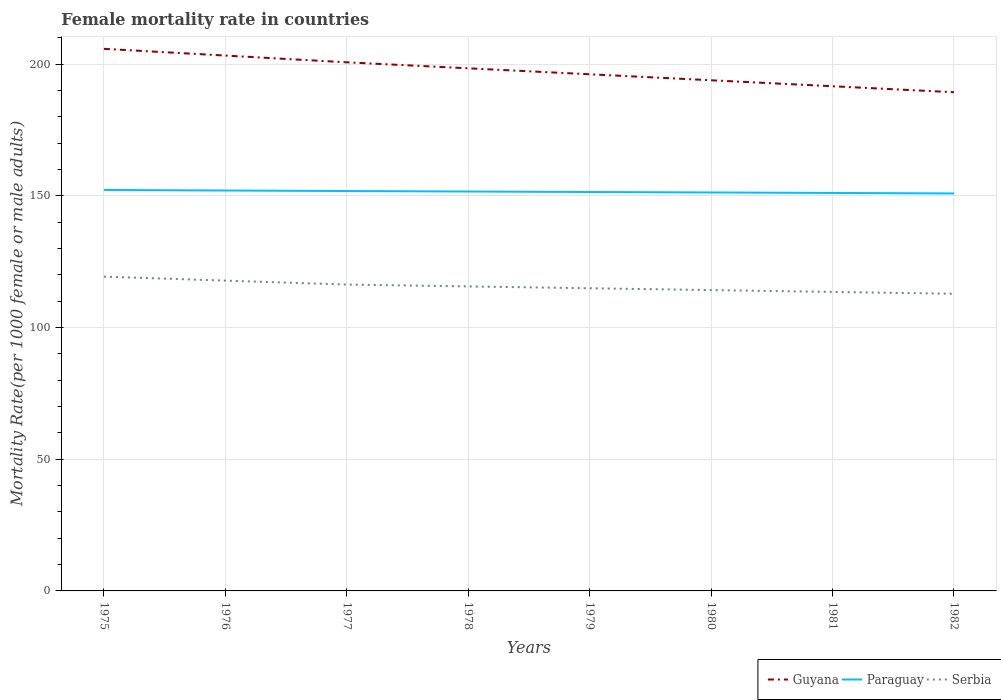Does the line corresponding to Guyana intersect with the line corresponding to Serbia?
Keep it short and to the point. No. Across all years, what is the maximum female mortality rate in Paraguay?
Offer a very short reply. 150.9. In which year was the female mortality rate in Guyana maximum?
Give a very brief answer. 1982. What is the total female mortality rate in Paraguay in the graph?
Ensure brevity in your answer.  0.57. What is the difference between the highest and the second highest female mortality rate in Guyana?
Keep it short and to the point. 16.48. Is the female mortality rate in Guyana strictly greater than the female mortality rate in Serbia over the years?
Offer a terse response. No. Does the graph contain any zero values?
Your answer should be very brief. No. How are the legend labels stacked?
Offer a very short reply. Horizontal. What is the title of the graph?
Ensure brevity in your answer.  Female mortality rate in countries. What is the label or title of the Y-axis?
Your response must be concise. Mortality Rate(per 1000 female or male adults). What is the Mortality Rate(per 1000 female or male adults) of Guyana in 1975?
Offer a terse response. 205.79. What is the Mortality Rate(per 1000 female or male adults) of Paraguay in 1975?
Make the answer very short. 152.21. What is the Mortality Rate(per 1000 female or male adults) of Serbia in 1975?
Give a very brief answer. 119.3. What is the Mortality Rate(per 1000 female or male adults) in Guyana in 1976?
Your answer should be very brief. 203.23. What is the Mortality Rate(per 1000 female or male adults) of Paraguay in 1976?
Provide a succinct answer. 152.01. What is the Mortality Rate(per 1000 female or male adults) of Serbia in 1976?
Keep it short and to the point. 117.8. What is the Mortality Rate(per 1000 female or male adults) of Guyana in 1977?
Your answer should be very brief. 200.67. What is the Mortality Rate(per 1000 female or male adults) of Paraguay in 1977?
Ensure brevity in your answer.  151.8. What is the Mortality Rate(per 1000 female or male adults) in Serbia in 1977?
Offer a very short reply. 116.3. What is the Mortality Rate(per 1000 female or male adults) in Guyana in 1978?
Offer a very short reply. 198.4. What is the Mortality Rate(per 1000 female or male adults) of Paraguay in 1978?
Give a very brief answer. 151.62. What is the Mortality Rate(per 1000 female or male adults) in Serbia in 1978?
Offer a very short reply. 115.6. What is the Mortality Rate(per 1000 female or male adults) in Guyana in 1979?
Keep it short and to the point. 196.13. What is the Mortality Rate(per 1000 female or male adults) in Paraguay in 1979?
Provide a succinct answer. 151.44. What is the Mortality Rate(per 1000 female or male adults) in Serbia in 1979?
Offer a very short reply. 114.9. What is the Mortality Rate(per 1000 female or male adults) of Guyana in 1980?
Your response must be concise. 193.86. What is the Mortality Rate(per 1000 female or male adults) in Paraguay in 1980?
Provide a succinct answer. 151.26. What is the Mortality Rate(per 1000 female or male adults) in Serbia in 1980?
Give a very brief answer. 114.2. What is the Mortality Rate(per 1000 female or male adults) in Guyana in 1981?
Offer a very short reply. 191.59. What is the Mortality Rate(per 1000 female or male adults) in Paraguay in 1981?
Offer a terse response. 151.08. What is the Mortality Rate(per 1000 female or male adults) in Serbia in 1981?
Provide a succinct answer. 113.5. What is the Mortality Rate(per 1000 female or male adults) of Guyana in 1982?
Your response must be concise. 189.31. What is the Mortality Rate(per 1000 female or male adults) in Paraguay in 1982?
Offer a terse response. 150.9. What is the Mortality Rate(per 1000 female or male adults) in Serbia in 1982?
Ensure brevity in your answer.  112.81. Across all years, what is the maximum Mortality Rate(per 1000 female or male adults) in Guyana?
Make the answer very short. 205.79. Across all years, what is the maximum Mortality Rate(per 1000 female or male adults) in Paraguay?
Your response must be concise. 152.21. Across all years, what is the maximum Mortality Rate(per 1000 female or male adults) of Serbia?
Your response must be concise. 119.3. Across all years, what is the minimum Mortality Rate(per 1000 female or male adults) in Guyana?
Your answer should be very brief. 189.31. Across all years, what is the minimum Mortality Rate(per 1000 female or male adults) in Paraguay?
Provide a short and direct response. 150.9. Across all years, what is the minimum Mortality Rate(per 1000 female or male adults) of Serbia?
Your answer should be very brief. 112.81. What is the total Mortality Rate(per 1000 female or male adults) of Guyana in the graph?
Your answer should be very brief. 1578.97. What is the total Mortality Rate(per 1000 female or male adults) of Paraguay in the graph?
Provide a succinct answer. 1212.32. What is the total Mortality Rate(per 1000 female or male adults) of Serbia in the graph?
Keep it short and to the point. 924.41. What is the difference between the Mortality Rate(per 1000 female or male adults) of Guyana in 1975 and that in 1976?
Make the answer very short. 2.56. What is the difference between the Mortality Rate(per 1000 female or male adults) in Paraguay in 1975 and that in 1976?
Your answer should be very brief. 0.2. What is the difference between the Mortality Rate(per 1000 female or male adults) in Serbia in 1975 and that in 1976?
Your answer should be very brief. 1.5. What is the difference between the Mortality Rate(per 1000 female or male adults) of Guyana in 1975 and that in 1977?
Provide a short and direct response. 5.12. What is the difference between the Mortality Rate(per 1000 female or male adults) of Paraguay in 1975 and that in 1977?
Provide a succinct answer. 0.41. What is the difference between the Mortality Rate(per 1000 female or male adults) of Serbia in 1975 and that in 1977?
Provide a succinct answer. 3. What is the difference between the Mortality Rate(per 1000 female or male adults) of Guyana in 1975 and that in 1978?
Offer a terse response. 7.39. What is the difference between the Mortality Rate(per 1000 female or male adults) in Paraguay in 1975 and that in 1978?
Your answer should be very brief. 0.59. What is the difference between the Mortality Rate(per 1000 female or male adults) in Serbia in 1975 and that in 1978?
Your answer should be very brief. 3.7. What is the difference between the Mortality Rate(per 1000 female or male adults) in Guyana in 1975 and that in 1979?
Offer a very short reply. 9.66. What is the difference between the Mortality Rate(per 1000 female or male adults) of Paraguay in 1975 and that in 1979?
Provide a succinct answer. 0.77. What is the difference between the Mortality Rate(per 1000 female or male adults) of Serbia in 1975 and that in 1979?
Ensure brevity in your answer.  4.4. What is the difference between the Mortality Rate(per 1000 female or male adults) in Guyana in 1975 and that in 1980?
Make the answer very short. 11.94. What is the difference between the Mortality Rate(per 1000 female or male adults) of Paraguay in 1975 and that in 1980?
Ensure brevity in your answer.  0.95. What is the difference between the Mortality Rate(per 1000 female or male adults) of Serbia in 1975 and that in 1980?
Keep it short and to the point. 5.1. What is the difference between the Mortality Rate(per 1000 female or male adults) in Guyana in 1975 and that in 1981?
Your response must be concise. 14.21. What is the difference between the Mortality Rate(per 1000 female or male adults) of Paraguay in 1975 and that in 1981?
Provide a short and direct response. 1.14. What is the difference between the Mortality Rate(per 1000 female or male adults) of Serbia in 1975 and that in 1981?
Your response must be concise. 5.8. What is the difference between the Mortality Rate(per 1000 female or male adults) of Guyana in 1975 and that in 1982?
Ensure brevity in your answer.  16.48. What is the difference between the Mortality Rate(per 1000 female or male adults) in Paraguay in 1975 and that in 1982?
Provide a short and direct response. 1.32. What is the difference between the Mortality Rate(per 1000 female or male adults) in Serbia in 1975 and that in 1982?
Provide a succinct answer. 6.49. What is the difference between the Mortality Rate(per 1000 female or male adults) of Guyana in 1976 and that in 1977?
Make the answer very short. 2.56. What is the difference between the Mortality Rate(per 1000 female or male adults) in Paraguay in 1976 and that in 1977?
Keep it short and to the point. 0.2. What is the difference between the Mortality Rate(per 1000 female or male adults) of Serbia in 1976 and that in 1977?
Your answer should be compact. 1.5. What is the difference between the Mortality Rate(per 1000 female or male adults) in Guyana in 1976 and that in 1978?
Provide a succinct answer. 4.83. What is the difference between the Mortality Rate(per 1000 female or male adults) in Paraguay in 1976 and that in 1978?
Provide a succinct answer. 0.39. What is the difference between the Mortality Rate(per 1000 female or male adults) of Serbia in 1976 and that in 1978?
Give a very brief answer. 2.2. What is the difference between the Mortality Rate(per 1000 female or male adults) in Guyana in 1976 and that in 1979?
Ensure brevity in your answer.  7.1. What is the difference between the Mortality Rate(per 1000 female or male adults) of Paraguay in 1976 and that in 1979?
Provide a succinct answer. 0.57. What is the difference between the Mortality Rate(per 1000 female or male adults) of Serbia in 1976 and that in 1979?
Make the answer very short. 2.9. What is the difference between the Mortality Rate(per 1000 female or male adults) in Guyana in 1976 and that in 1980?
Your answer should be compact. 9.37. What is the difference between the Mortality Rate(per 1000 female or male adults) of Paraguay in 1976 and that in 1980?
Your answer should be very brief. 0.75. What is the difference between the Mortality Rate(per 1000 female or male adults) in Serbia in 1976 and that in 1980?
Ensure brevity in your answer.  3.6. What is the difference between the Mortality Rate(per 1000 female or male adults) in Guyana in 1976 and that in 1981?
Provide a succinct answer. 11.64. What is the difference between the Mortality Rate(per 1000 female or male adults) in Paraguay in 1976 and that in 1981?
Offer a terse response. 0.93. What is the difference between the Mortality Rate(per 1000 female or male adults) of Serbia in 1976 and that in 1981?
Give a very brief answer. 4.29. What is the difference between the Mortality Rate(per 1000 female or male adults) in Guyana in 1976 and that in 1982?
Keep it short and to the point. 13.91. What is the difference between the Mortality Rate(per 1000 female or male adults) in Paraguay in 1976 and that in 1982?
Offer a very short reply. 1.11. What is the difference between the Mortality Rate(per 1000 female or male adults) of Serbia in 1976 and that in 1982?
Offer a terse response. 4.99. What is the difference between the Mortality Rate(per 1000 female or male adults) in Guyana in 1977 and that in 1978?
Your response must be concise. 2.27. What is the difference between the Mortality Rate(per 1000 female or male adults) of Paraguay in 1977 and that in 1978?
Offer a very short reply. 0.18. What is the difference between the Mortality Rate(per 1000 female or male adults) in Serbia in 1977 and that in 1978?
Your response must be concise. 0.7. What is the difference between the Mortality Rate(per 1000 female or male adults) in Guyana in 1977 and that in 1979?
Give a very brief answer. 4.54. What is the difference between the Mortality Rate(per 1000 female or male adults) in Paraguay in 1977 and that in 1979?
Offer a very short reply. 0.36. What is the difference between the Mortality Rate(per 1000 female or male adults) of Serbia in 1977 and that in 1979?
Provide a succinct answer. 1.4. What is the difference between the Mortality Rate(per 1000 female or male adults) of Guyana in 1977 and that in 1980?
Make the answer very short. 6.81. What is the difference between the Mortality Rate(per 1000 female or male adults) of Paraguay in 1977 and that in 1980?
Ensure brevity in your answer.  0.55. What is the difference between the Mortality Rate(per 1000 female or male adults) of Serbia in 1977 and that in 1980?
Ensure brevity in your answer.  2.1. What is the difference between the Mortality Rate(per 1000 female or male adults) of Guyana in 1977 and that in 1981?
Your response must be concise. 9.08. What is the difference between the Mortality Rate(per 1000 female or male adults) in Paraguay in 1977 and that in 1981?
Make the answer very short. 0.73. What is the difference between the Mortality Rate(per 1000 female or male adults) in Serbia in 1977 and that in 1981?
Keep it short and to the point. 2.79. What is the difference between the Mortality Rate(per 1000 female or male adults) of Guyana in 1977 and that in 1982?
Keep it short and to the point. 11.35. What is the difference between the Mortality Rate(per 1000 female or male adults) in Paraguay in 1977 and that in 1982?
Make the answer very short. 0.91. What is the difference between the Mortality Rate(per 1000 female or male adults) of Serbia in 1977 and that in 1982?
Provide a short and direct response. 3.49. What is the difference between the Mortality Rate(per 1000 female or male adults) in Guyana in 1978 and that in 1979?
Offer a terse response. 2.27. What is the difference between the Mortality Rate(per 1000 female or male adults) in Paraguay in 1978 and that in 1979?
Offer a terse response. 0.18. What is the difference between the Mortality Rate(per 1000 female or male adults) in Serbia in 1978 and that in 1979?
Your answer should be very brief. 0.7. What is the difference between the Mortality Rate(per 1000 female or male adults) in Guyana in 1978 and that in 1980?
Your answer should be compact. 4.54. What is the difference between the Mortality Rate(per 1000 female or male adults) in Paraguay in 1978 and that in 1980?
Offer a terse response. 0.36. What is the difference between the Mortality Rate(per 1000 female or male adults) of Serbia in 1978 and that in 1980?
Your answer should be very brief. 1.4. What is the difference between the Mortality Rate(per 1000 female or male adults) of Guyana in 1978 and that in 1981?
Make the answer very short. 6.81. What is the difference between the Mortality Rate(per 1000 female or male adults) in Paraguay in 1978 and that in 1981?
Your answer should be very brief. 0.55. What is the difference between the Mortality Rate(per 1000 female or male adults) in Serbia in 1978 and that in 1981?
Offer a very short reply. 2.1. What is the difference between the Mortality Rate(per 1000 female or male adults) of Guyana in 1978 and that in 1982?
Your response must be concise. 9.08. What is the difference between the Mortality Rate(per 1000 female or male adults) in Paraguay in 1978 and that in 1982?
Your response must be concise. 0.73. What is the difference between the Mortality Rate(per 1000 female or male adults) in Serbia in 1978 and that in 1982?
Provide a short and direct response. 2.79. What is the difference between the Mortality Rate(per 1000 female or male adults) in Guyana in 1979 and that in 1980?
Offer a very short reply. 2.27. What is the difference between the Mortality Rate(per 1000 female or male adults) of Paraguay in 1979 and that in 1980?
Provide a succinct answer. 0.18. What is the difference between the Mortality Rate(per 1000 female or male adults) of Serbia in 1979 and that in 1980?
Give a very brief answer. 0.7. What is the difference between the Mortality Rate(per 1000 female or male adults) in Guyana in 1979 and that in 1981?
Provide a short and direct response. 4.54. What is the difference between the Mortality Rate(per 1000 female or male adults) in Paraguay in 1979 and that in 1981?
Provide a short and direct response. 0.36. What is the difference between the Mortality Rate(per 1000 female or male adults) in Serbia in 1979 and that in 1981?
Keep it short and to the point. 1.4. What is the difference between the Mortality Rate(per 1000 female or male adults) of Guyana in 1979 and that in 1982?
Your response must be concise. 6.81. What is the difference between the Mortality Rate(per 1000 female or male adults) in Paraguay in 1979 and that in 1982?
Your response must be concise. 0.55. What is the difference between the Mortality Rate(per 1000 female or male adults) in Serbia in 1979 and that in 1982?
Your response must be concise. 2.1. What is the difference between the Mortality Rate(per 1000 female or male adults) in Guyana in 1980 and that in 1981?
Give a very brief answer. 2.27. What is the difference between the Mortality Rate(per 1000 female or male adults) of Paraguay in 1980 and that in 1981?
Provide a succinct answer. 0.18. What is the difference between the Mortality Rate(per 1000 female or male adults) in Serbia in 1980 and that in 1981?
Your answer should be compact. 0.7. What is the difference between the Mortality Rate(per 1000 female or male adults) of Guyana in 1980 and that in 1982?
Make the answer very short. 4.54. What is the difference between the Mortality Rate(per 1000 female or male adults) of Paraguay in 1980 and that in 1982?
Provide a short and direct response. 0.36. What is the difference between the Mortality Rate(per 1000 female or male adults) in Serbia in 1980 and that in 1982?
Your answer should be compact. 1.4. What is the difference between the Mortality Rate(per 1000 female or male adults) in Guyana in 1981 and that in 1982?
Your answer should be very brief. 2.27. What is the difference between the Mortality Rate(per 1000 female or male adults) in Paraguay in 1981 and that in 1982?
Offer a terse response. 0.18. What is the difference between the Mortality Rate(per 1000 female or male adults) in Serbia in 1981 and that in 1982?
Your answer should be very brief. 0.7. What is the difference between the Mortality Rate(per 1000 female or male adults) in Guyana in 1975 and the Mortality Rate(per 1000 female or male adults) in Paraguay in 1976?
Offer a terse response. 53.78. What is the difference between the Mortality Rate(per 1000 female or male adults) in Guyana in 1975 and the Mortality Rate(per 1000 female or male adults) in Serbia in 1976?
Your answer should be very brief. 87.99. What is the difference between the Mortality Rate(per 1000 female or male adults) in Paraguay in 1975 and the Mortality Rate(per 1000 female or male adults) in Serbia in 1976?
Offer a very short reply. 34.41. What is the difference between the Mortality Rate(per 1000 female or male adults) of Guyana in 1975 and the Mortality Rate(per 1000 female or male adults) of Paraguay in 1977?
Your answer should be compact. 53.99. What is the difference between the Mortality Rate(per 1000 female or male adults) of Guyana in 1975 and the Mortality Rate(per 1000 female or male adults) of Serbia in 1977?
Your answer should be very brief. 89.49. What is the difference between the Mortality Rate(per 1000 female or male adults) of Paraguay in 1975 and the Mortality Rate(per 1000 female or male adults) of Serbia in 1977?
Provide a short and direct response. 35.91. What is the difference between the Mortality Rate(per 1000 female or male adults) of Guyana in 1975 and the Mortality Rate(per 1000 female or male adults) of Paraguay in 1978?
Your response must be concise. 54.17. What is the difference between the Mortality Rate(per 1000 female or male adults) of Guyana in 1975 and the Mortality Rate(per 1000 female or male adults) of Serbia in 1978?
Your response must be concise. 90.19. What is the difference between the Mortality Rate(per 1000 female or male adults) of Paraguay in 1975 and the Mortality Rate(per 1000 female or male adults) of Serbia in 1978?
Keep it short and to the point. 36.61. What is the difference between the Mortality Rate(per 1000 female or male adults) in Guyana in 1975 and the Mortality Rate(per 1000 female or male adults) in Paraguay in 1979?
Provide a short and direct response. 54.35. What is the difference between the Mortality Rate(per 1000 female or male adults) in Guyana in 1975 and the Mortality Rate(per 1000 female or male adults) in Serbia in 1979?
Give a very brief answer. 90.89. What is the difference between the Mortality Rate(per 1000 female or male adults) in Paraguay in 1975 and the Mortality Rate(per 1000 female or male adults) in Serbia in 1979?
Give a very brief answer. 37.31. What is the difference between the Mortality Rate(per 1000 female or male adults) of Guyana in 1975 and the Mortality Rate(per 1000 female or male adults) of Paraguay in 1980?
Keep it short and to the point. 54.53. What is the difference between the Mortality Rate(per 1000 female or male adults) of Guyana in 1975 and the Mortality Rate(per 1000 female or male adults) of Serbia in 1980?
Offer a terse response. 91.59. What is the difference between the Mortality Rate(per 1000 female or male adults) of Paraguay in 1975 and the Mortality Rate(per 1000 female or male adults) of Serbia in 1980?
Provide a short and direct response. 38.01. What is the difference between the Mortality Rate(per 1000 female or male adults) of Guyana in 1975 and the Mortality Rate(per 1000 female or male adults) of Paraguay in 1981?
Your answer should be compact. 54.71. What is the difference between the Mortality Rate(per 1000 female or male adults) of Guyana in 1975 and the Mortality Rate(per 1000 female or male adults) of Serbia in 1981?
Your response must be concise. 92.29. What is the difference between the Mortality Rate(per 1000 female or male adults) in Paraguay in 1975 and the Mortality Rate(per 1000 female or male adults) in Serbia in 1981?
Keep it short and to the point. 38.71. What is the difference between the Mortality Rate(per 1000 female or male adults) in Guyana in 1975 and the Mortality Rate(per 1000 female or male adults) in Paraguay in 1982?
Offer a terse response. 54.9. What is the difference between the Mortality Rate(per 1000 female or male adults) in Guyana in 1975 and the Mortality Rate(per 1000 female or male adults) in Serbia in 1982?
Offer a terse response. 92.99. What is the difference between the Mortality Rate(per 1000 female or male adults) in Paraguay in 1975 and the Mortality Rate(per 1000 female or male adults) in Serbia in 1982?
Provide a short and direct response. 39.41. What is the difference between the Mortality Rate(per 1000 female or male adults) of Guyana in 1976 and the Mortality Rate(per 1000 female or male adults) of Paraguay in 1977?
Offer a terse response. 51.42. What is the difference between the Mortality Rate(per 1000 female or male adults) in Guyana in 1976 and the Mortality Rate(per 1000 female or male adults) in Serbia in 1977?
Provide a short and direct response. 86.93. What is the difference between the Mortality Rate(per 1000 female or male adults) of Paraguay in 1976 and the Mortality Rate(per 1000 female or male adults) of Serbia in 1977?
Make the answer very short. 35.71. What is the difference between the Mortality Rate(per 1000 female or male adults) of Guyana in 1976 and the Mortality Rate(per 1000 female or male adults) of Paraguay in 1978?
Provide a short and direct response. 51.61. What is the difference between the Mortality Rate(per 1000 female or male adults) in Guyana in 1976 and the Mortality Rate(per 1000 female or male adults) in Serbia in 1978?
Ensure brevity in your answer.  87.63. What is the difference between the Mortality Rate(per 1000 female or male adults) in Paraguay in 1976 and the Mortality Rate(per 1000 female or male adults) in Serbia in 1978?
Keep it short and to the point. 36.41. What is the difference between the Mortality Rate(per 1000 female or male adults) of Guyana in 1976 and the Mortality Rate(per 1000 female or male adults) of Paraguay in 1979?
Offer a very short reply. 51.79. What is the difference between the Mortality Rate(per 1000 female or male adults) of Guyana in 1976 and the Mortality Rate(per 1000 female or male adults) of Serbia in 1979?
Ensure brevity in your answer.  88.33. What is the difference between the Mortality Rate(per 1000 female or male adults) in Paraguay in 1976 and the Mortality Rate(per 1000 female or male adults) in Serbia in 1979?
Provide a succinct answer. 37.11. What is the difference between the Mortality Rate(per 1000 female or male adults) of Guyana in 1976 and the Mortality Rate(per 1000 female or male adults) of Paraguay in 1980?
Provide a short and direct response. 51.97. What is the difference between the Mortality Rate(per 1000 female or male adults) in Guyana in 1976 and the Mortality Rate(per 1000 female or male adults) in Serbia in 1980?
Make the answer very short. 89.03. What is the difference between the Mortality Rate(per 1000 female or male adults) of Paraguay in 1976 and the Mortality Rate(per 1000 female or male adults) of Serbia in 1980?
Your response must be concise. 37.81. What is the difference between the Mortality Rate(per 1000 female or male adults) in Guyana in 1976 and the Mortality Rate(per 1000 female or male adults) in Paraguay in 1981?
Ensure brevity in your answer.  52.15. What is the difference between the Mortality Rate(per 1000 female or male adults) of Guyana in 1976 and the Mortality Rate(per 1000 female or male adults) of Serbia in 1981?
Give a very brief answer. 89.73. What is the difference between the Mortality Rate(per 1000 female or male adults) in Paraguay in 1976 and the Mortality Rate(per 1000 female or male adults) in Serbia in 1981?
Provide a short and direct response. 38.5. What is the difference between the Mortality Rate(per 1000 female or male adults) of Guyana in 1976 and the Mortality Rate(per 1000 female or male adults) of Paraguay in 1982?
Make the answer very short. 52.33. What is the difference between the Mortality Rate(per 1000 female or male adults) of Guyana in 1976 and the Mortality Rate(per 1000 female or male adults) of Serbia in 1982?
Your response must be concise. 90.42. What is the difference between the Mortality Rate(per 1000 female or male adults) in Paraguay in 1976 and the Mortality Rate(per 1000 female or male adults) in Serbia in 1982?
Your answer should be very brief. 39.2. What is the difference between the Mortality Rate(per 1000 female or male adults) in Guyana in 1977 and the Mortality Rate(per 1000 female or male adults) in Paraguay in 1978?
Provide a short and direct response. 49.05. What is the difference between the Mortality Rate(per 1000 female or male adults) of Guyana in 1977 and the Mortality Rate(per 1000 female or male adults) of Serbia in 1978?
Provide a succinct answer. 85.07. What is the difference between the Mortality Rate(per 1000 female or male adults) in Paraguay in 1977 and the Mortality Rate(per 1000 female or male adults) in Serbia in 1978?
Ensure brevity in your answer.  36.2. What is the difference between the Mortality Rate(per 1000 female or male adults) of Guyana in 1977 and the Mortality Rate(per 1000 female or male adults) of Paraguay in 1979?
Give a very brief answer. 49.23. What is the difference between the Mortality Rate(per 1000 female or male adults) of Guyana in 1977 and the Mortality Rate(per 1000 female or male adults) of Serbia in 1979?
Give a very brief answer. 85.77. What is the difference between the Mortality Rate(per 1000 female or male adults) in Paraguay in 1977 and the Mortality Rate(per 1000 female or male adults) in Serbia in 1979?
Offer a terse response. 36.9. What is the difference between the Mortality Rate(per 1000 female or male adults) in Guyana in 1977 and the Mortality Rate(per 1000 female or male adults) in Paraguay in 1980?
Provide a short and direct response. 49.41. What is the difference between the Mortality Rate(per 1000 female or male adults) of Guyana in 1977 and the Mortality Rate(per 1000 female or male adults) of Serbia in 1980?
Offer a very short reply. 86.47. What is the difference between the Mortality Rate(per 1000 female or male adults) in Paraguay in 1977 and the Mortality Rate(per 1000 female or male adults) in Serbia in 1980?
Make the answer very short. 37.6. What is the difference between the Mortality Rate(per 1000 female or male adults) in Guyana in 1977 and the Mortality Rate(per 1000 female or male adults) in Paraguay in 1981?
Your response must be concise. 49.59. What is the difference between the Mortality Rate(per 1000 female or male adults) of Guyana in 1977 and the Mortality Rate(per 1000 female or male adults) of Serbia in 1981?
Provide a succinct answer. 87.16. What is the difference between the Mortality Rate(per 1000 female or male adults) of Paraguay in 1977 and the Mortality Rate(per 1000 female or male adults) of Serbia in 1981?
Offer a terse response. 38.3. What is the difference between the Mortality Rate(per 1000 female or male adults) of Guyana in 1977 and the Mortality Rate(per 1000 female or male adults) of Paraguay in 1982?
Offer a very short reply. 49.77. What is the difference between the Mortality Rate(per 1000 female or male adults) of Guyana in 1977 and the Mortality Rate(per 1000 female or male adults) of Serbia in 1982?
Offer a terse response. 87.86. What is the difference between the Mortality Rate(per 1000 female or male adults) in Paraguay in 1977 and the Mortality Rate(per 1000 female or male adults) in Serbia in 1982?
Offer a terse response. 39. What is the difference between the Mortality Rate(per 1000 female or male adults) of Guyana in 1978 and the Mortality Rate(per 1000 female or male adults) of Paraguay in 1979?
Your answer should be very brief. 46.96. What is the difference between the Mortality Rate(per 1000 female or male adults) in Guyana in 1978 and the Mortality Rate(per 1000 female or male adults) in Serbia in 1979?
Offer a very short reply. 83.5. What is the difference between the Mortality Rate(per 1000 female or male adults) in Paraguay in 1978 and the Mortality Rate(per 1000 female or male adults) in Serbia in 1979?
Your answer should be very brief. 36.72. What is the difference between the Mortality Rate(per 1000 female or male adults) of Guyana in 1978 and the Mortality Rate(per 1000 female or male adults) of Paraguay in 1980?
Offer a very short reply. 47.14. What is the difference between the Mortality Rate(per 1000 female or male adults) in Guyana in 1978 and the Mortality Rate(per 1000 female or male adults) in Serbia in 1980?
Provide a succinct answer. 84.19. What is the difference between the Mortality Rate(per 1000 female or male adults) in Paraguay in 1978 and the Mortality Rate(per 1000 female or male adults) in Serbia in 1980?
Ensure brevity in your answer.  37.42. What is the difference between the Mortality Rate(per 1000 female or male adults) of Guyana in 1978 and the Mortality Rate(per 1000 female or male adults) of Paraguay in 1981?
Offer a terse response. 47.32. What is the difference between the Mortality Rate(per 1000 female or male adults) of Guyana in 1978 and the Mortality Rate(per 1000 female or male adults) of Serbia in 1981?
Offer a terse response. 84.89. What is the difference between the Mortality Rate(per 1000 female or male adults) in Paraguay in 1978 and the Mortality Rate(per 1000 female or male adults) in Serbia in 1981?
Your response must be concise. 38.12. What is the difference between the Mortality Rate(per 1000 female or male adults) of Guyana in 1978 and the Mortality Rate(per 1000 female or male adults) of Paraguay in 1982?
Ensure brevity in your answer.  47.5. What is the difference between the Mortality Rate(per 1000 female or male adults) of Guyana in 1978 and the Mortality Rate(per 1000 female or male adults) of Serbia in 1982?
Provide a short and direct response. 85.59. What is the difference between the Mortality Rate(per 1000 female or male adults) of Paraguay in 1978 and the Mortality Rate(per 1000 female or male adults) of Serbia in 1982?
Your response must be concise. 38.82. What is the difference between the Mortality Rate(per 1000 female or male adults) of Guyana in 1979 and the Mortality Rate(per 1000 female or male adults) of Paraguay in 1980?
Your answer should be compact. 44.87. What is the difference between the Mortality Rate(per 1000 female or male adults) of Guyana in 1979 and the Mortality Rate(per 1000 female or male adults) of Serbia in 1980?
Offer a very short reply. 81.92. What is the difference between the Mortality Rate(per 1000 female or male adults) of Paraguay in 1979 and the Mortality Rate(per 1000 female or male adults) of Serbia in 1980?
Provide a short and direct response. 37.24. What is the difference between the Mortality Rate(per 1000 female or male adults) in Guyana in 1979 and the Mortality Rate(per 1000 female or male adults) in Paraguay in 1981?
Make the answer very short. 45.05. What is the difference between the Mortality Rate(per 1000 female or male adults) in Guyana in 1979 and the Mortality Rate(per 1000 female or male adults) in Serbia in 1981?
Provide a short and direct response. 82.62. What is the difference between the Mortality Rate(per 1000 female or male adults) in Paraguay in 1979 and the Mortality Rate(per 1000 female or male adults) in Serbia in 1981?
Provide a succinct answer. 37.94. What is the difference between the Mortality Rate(per 1000 female or male adults) in Guyana in 1979 and the Mortality Rate(per 1000 female or male adults) in Paraguay in 1982?
Keep it short and to the point. 45.23. What is the difference between the Mortality Rate(per 1000 female or male adults) in Guyana in 1979 and the Mortality Rate(per 1000 female or male adults) in Serbia in 1982?
Your answer should be very brief. 83.32. What is the difference between the Mortality Rate(per 1000 female or male adults) of Paraguay in 1979 and the Mortality Rate(per 1000 female or male adults) of Serbia in 1982?
Offer a terse response. 38.63. What is the difference between the Mortality Rate(per 1000 female or male adults) in Guyana in 1980 and the Mortality Rate(per 1000 female or male adults) in Paraguay in 1981?
Your answer should be compact. 42.78. What is the difference between the Mortality Rate(per 1000 female or male adults) of Guyana in 1980 and the Mortality Rate(per 1000 female or male adults) of Serbia in 1981?
Your answer should be very brief. 80.35. What is the difference between the Mortality Rate(per 1000 female or male adults) of Paraguay in 1980 and the Mortality Rate(per 1000 female or male adults) of Serbia in 1981?
Your answer should be very brief. 37.76. What is the difference between the Mortality Rate(per 1000 female or male adults) in Guyana in 1980 and the Mortality Rate(per 1000 female or male adults) in Paraguay in 1982?
Give a very brief answer. 42.96. What is the difference between the Mortality Rate(per 1000 female or male adults) of Guyana in 1980 and the Mortality Rate(per 1000 female or male adults) of Serbia in 1982?
Keep it short and to the point. 81.05. What is the difference between the Mortality Rate(per 1000 female or male adults) of Paraguay in 1980 and the Mortality Rate(per 1000 female or male adults) of Serbia in 1982?
Keep it short and to the point. 38.45. What is the difference between the Mortality Rate(per 1000 female or male adults) in Guyana in 1981 and the Mortality Rate(per 1000 female or male adults) in Paraguay in 1982?
Give a very brief answer. 40.69. What is the difference between the Mortality Rate(per 1000 female or male adults) in Guyana in 1981 and the Mortality Rate(per 1000 female or male adults) in Serbia in 1982?
Provide a succinct answer. 78.78. What is the difference between the Mortality Rate(per 1000 female or male adults) in Paraguay in 1981 and the Mortality Rate(per 1000 female or male adults) in Serbia in 1982?
Give a very brief answer. 38.27. What is the average Mortality Rate(per 1000 female or male adults) of Guyana per year?
Your answer should be very brief. 197.37. What is the average Mortality Rate(per 1000 female or male adults) in Paraguay per year?
Offer a terse response. 151.54. What is the average Mortality Rate(per 1000 female or male adults) in Serbia per year?
Offer a terse response. 115.55. In the year 1975, what is the difference between the Mortality Rate(per 1000 female or male adults) in Guyana and Mortality Rate(per 1000 female or male adults) in Paraguay?
Offer a very short reply. 53.58. In the year 1975, what is the difference between the Mortality Rate(per 1000 female or male adults) of Guyana and Mortality Rate(per 1000 female or male adults) of Serbia?
Your answer should be compact. 86.49. In the year 1975, what is the difference between the Mortality Rate(per 1000 female or male adults) in Paraguay and Mortality Rate(per 1000 female or male adults) in Serbia?
Offer a very short reply. 32.91. In the year 1976, what is the difference between the Mortality Rate(per 1000 female or male adults) in Guyana and Mortality Rate(per 1000 female or male adults) in Paraguay?
Offer a terse response. 51.22. In the year 1976, what is the difference between the Mortality Rate(per 1000 female or male adults) of Guyana and Mortality Rate(per 1000 female or male adults) of Serbia?
Offer a very short reply. 85.43. In the year 1976, what is the difference between the Mortality Rate(per 1000 female or male adults) of Paraguay and Mortality Rate(per 1000 female or male adults) of Serbia?
Make the answer very short. 34.21. In the year 1977, what is the difference between the Mortality Rate(per 1000 female or male adults) of Guyana and Mortality Rate(per 1000 female or male adults) of Paraguay?
Give a very brief answer. 48.86. In the year 1977, what is the difference between the Mortality Rate(per 1000 female or male adults) of Guyana and Mortality Rate(per 1000 female or male adults) of Serbia?
Ensure brevity in your answer.  84.37. In the year 1977, what is the difference between the Mortality Rate(per 1000 female or male adults) of Paraguay and Mortality Rate(per 1000 female or male adults) of Serbia?
Offer a terse response. 35.51. In the year 1978, what is the difference between the Mortality Rate(per 1000 female or male adults) in Guyana and Mortality Rate(per 1000 female or male adults) in Paraguay?
Make the answer very short. 46.77. In the year 1978, what is the difference between the Mortality Rate(per 1000 female or male adults) of Guyana and Mortality Rate(per 1000 female or male adults) of Serbia?
Provide a short and direct response. 82.8. In the year 1978, what is the difference between the Mortality Rate(per 1000 female or male adults) of Paraguay and Mortality Rate(per 1000 female or male adults) of Serbia?
Your response must be concise. 36.02. In the year 1979, what is the difference between the Mortality Rate(per 1000 female or male adults) of Guyana and Mortality Rate(per 1000 female or male adults) of Paraguay?
Offer a very short reply. 44.69. In the year 1979, what is the difference between the Mortality Rate(per 1000 female or male adults) in Guyana and Mortality Rate(per 1000 female or male adults) in Serbia?
Offer a terse response. 81.23. In the year 1979, what is the difference between the Mortality Rate(per 1000 female or male adults) of Paraguay and Mortality Rate(per 1000 female or male adults) of Serbia?
Give a very brief answer. 36.54. In the year 1980, what is the difference between the Mortality Rate(per 1000 female or male adults) in Guyana and Mortality Rate(per 1000 female or male adults) in Paraguay?
Provide a short and direct response. 42.6. In the year 1980, what is the difference between the Mortality Rate(per 1000 female or male adults) of Guyana and Mortality Rate(per 1000 female or male adults) of Serbia?
Your answer should be compact. 79.65. In the year 1980, what is the difference between the Mortality Rate(per 1000 female or male adults) of Paraguay and Mortality Rate(per 1000 female or male adults) of Serbia?
Make the answer very short. 37.06. In the year 1981, what is the difference between the Mortality Rate(per 1000 female or male adults) in Guyana and Mortality Rate(per 1000 female or male adults) in Paraguay?
Give a very brief answer. 40.51. In the year 1981, what is the difference between the Mortality Rate(per 1000 female or male adults) of Guyana and Mortality Rate(per 1000 female or male adults) of Serbia?
Your answer should be compact. 78.08. In the year 1981, what is the difference between the Mortality Rate(per 1000 female or male adults) of Paraguay and Mortality Rate(per 1000 female or male adults) of Serbia?
Offer a terse response. 37.57. In the year 1982, what is the difference between the Mortality Rate(per 1000 female or male adults) in Guyana and Mortality Rate(per 1000 female or male adults) in Paraguay?
Your answer should be very brief. 38.42. In the year 1982, what is the difference between the Mortality Rate(per 1000 female or male adults) of Guyana and Mortality Rate(per 1000 female or male adults) of Serbia?
Offer a very short reply. 76.51. In the year 1982, what is the difference between the Mortality Rate(per 1000 female or male adults) of Paraguay and Mortality Rate(per 1000 female or male adults) of Serbia?
Offer a very short reply. 38.09. What is the ratio of the Mortality Rate(per 1000 female or male adults) of Guyana in 1975 to that in 1976?
Your answer should be compact. 1.01. What is the ratio of the Mortality Rate(per 1000 female or male adults) in Serbia in 1975 to that in 1976?
Provide a succinct answer. 1.01. What is the ratio of the Mortality Rate(per 1000 female or male adults) in Guyana in 1975 to that in 1977?
Your response must be concise. 1.03. What is the ratio of the Mortality Rate(per 1000 female or male adults) of Paraguay in 1975 to that in 1977?
Provide a succinct answer. 1. What is the ratio of the Mortality Rate(per 1000 female or male adults) in Serbia in 1975 to that in 1977?
Ensure brevity in your answer.  1.03. What is the ratio of the Mortality Rate(per 1000 female or male adults) in Guyana in 1975 to that in 1978?
Keep it short and to the point. 1.04. What is the ratio of the Mortality Rate(per 1000 female or male adults) in Paraguay in 1975 to that in 1978?
Your answer should be very brief. 1. What is the ratio of the Mortality Rate(per 1000 female or male adults) of Serbia in 1975 to that in 1978?
Offer a terse response. 1.03. What is the ratio of the Mortality Rate(per 1000 female or male adults) of Guyana in 1975 to that in 1979?
Provide a short and direct response. 1.05. What is the ratio of the Mortality Rate(per 1000 female or male adults) of Serbia in 1975 to that in 1979?
Keep it short and to the point. 1.04. What is the ratio of the Mortality Rate(per 1000 female or male adults) of Guyana in 1975 to that in 1980?
Give a very brief answer. 1.06. What is the ratio of the Mortality Rate(per 1000 female or male adults) of Paraguay in 1975 to that in 1980?
Ensure brevity in your answer.  1.01. What is the ratio of the Mortality Rate(per 1000 female or male adults) in Serbia in 1975 to that in 1980?
Offer a very short reply. 1.04. What is the ratio of the Mortality Rate(per 1000 female or male adults) in Guyana in 1975 to that in 1981?
Give a very brief answer. 1.07. What is the ratio of the Mortality Rate(per 1000 female or male adults) in Paraguay in 1975 to that in 1981?
Your response must be concise. 1.01. What is the ratio of the Mortality Rate(per 1000 female or male adults) of Serbia in 1975 to that in 1981?
Ensure brevity in your answer.  1.05. What is the ratio of the Mortality Rate(per 1000 female or male adults) of Guyana in 1975 to that in 1982?
Provide a short and direct response. 1.09. What is the ratio of the Mortality Rate(per 1000 female or male adults) of Paraguay in 1975 to that in 1982?
Make the answer very short. 1.01. What is the ratio of the Mortality Rate(per 1000 female or male adults) in Serbia in 1975 to that in 1982?
Provide a succinct answer. 1.06. What is the ratio of the Mortality Rate(per 1000 female or male adults) of Guyana in 1976 to that in 1977?
Your response must be concise. 1.01. What is the ratio of the Mortality Rate(per 1000 female or male adults) in Paraguay in 1976 to that in 1977?
Ensure brevity in your answer.  1. What is the ratio of the Mortality Rate(per 1000 female or male adults) in Serbia in 1976 to that in 1977?
Provide a short and direct response. 1.01. What is the ratio of the Mortality Rate(per 1000 female or male adults) of Guyana in 1976 to that in 1978?
Ensure brevity in your answer.  1.02. What is the ratio of the Mortality Rate(per 1000 female or male adults) in Paraguay in 1976 to that in 1978?
Offer a very short reply. 1. What is the ratio of the Mortality Rate(per 1000 female or male adults) of Guyana in 1976 to that in 1979?
Offer a terse response. 1.04. What is the ratio of the Mortality Rate(per 1000 female or male adults) in Paraguay in 1976 to that in 1979?
Ensure brevity in your answer.  1. What is the ratio of the Mortality Rate(per 1000 female or male adults) in Serbia in 1976 to that in 1979?
Offer a very short reply. 1.03. What is the ratio of the Mortality Rate(per 1000 female or male adults) in Guyana in 1976 to that in 1980?
Give a very brief answer. 1.05. What is the ratio of the Mortality Rate(per 1000 female or male adults) in Paraguay in 1976 to that in 1980?
Provide a succinct answer. 1. What is the ratio of the Mortality Rate(per 1000 female or male adults) in Serbia in 1976 to that in 1980?
Keep it short and to the point. 1.03. What is the ratio of the Mortality Rate(per 1000 female or male adults) of Guyana in 1976 to that in 1981?
Make the answer very short. 1.06. What is the ratio of the Mortality Rate(per 1000 female or male adults) in Serbia in 1976 to that in 1981?
Ensure brevity in your answer.  1.04. What is the ratio of the Mortality Rate(per 1000 female or male adults) of Guyana in 1976 to that in 1982?
Offer a terse response. 1.07. What is the ratio of the Mortality Rate(per 1000 female or male adults) of Paraguay in 1976 to that in 1982?
Offer a very short reply. 1.01. What is the ratio of the Mortality Rate(per 1000 female or male adults) of Serbia in 1976 to that in 1982?
Your answer should be compact. 1.04. What is the ratio of the Mortality Rate(per 1000 female or male adults) in Guyana in 1977 to that in 1978?
Keep it short and to the point. 1.01. What is the ratio of the Mortality Rate(per 1000 female or male adults) in Paraguay in 1977 to that in 1978?
Your answer should be compact. 1. What is the ratio of the Mortality Rate(per 1000 female or male adults) in Guyana in 1977 to that in 1979?
Your answer should be compact. 1.02. What is the ratio of the Mortality Rate(per 1000 female or male adults) in Serbia in 1977 to that in 1979?
Keep it short and to the point. 1.01. What is the ratio of the Mortality Rate(per 1000 female or male adults) of Guyana in 1977 to that in 1980?
Offer a terse response. 1.04. What is the ratio of the Mortality Rate(per 1000 female or male adults) in Serbia in 1977 to that in 1980?
Give a very brief answer. 1.02. What is the ratio of the Mortality Rate(per 1000 female or male adults) in Guyana in 1977 to that in 1981?
Provide a succinct answer. 1.05. What is the ratio of the Mortality Rate(per 1000 female or male adults) in Paraguay in 1977 to that in 1981?
Offer a terse response. 1. What is the ratio of the Mortality Rate(per 1000 female or male adults) of Serbia in 1977 to that in 1981?
Ensure brevity in your answer.  1.02. What is the ratio of the Mortality Rate(per 1000 female or male adults) in Guyana in 1977 to that in 1982?
Your response must be concise. 1.06. What is the ratio of the Mortality Rate(per 1000 female or male adults) in Serbia in 1977 to that in 1982?
Give a very brief answer. 1.03. What is the ratio of the Mortality Rate(per 1000 female or male adults) of Guyana in 1978 to that in 1979?
Ensure brevity in your answer.  1.01. What is the ratio of the Mortality Rate(per 1000 female or male adults) of Guyana in 1978 to that in 1980?
Your answer should be very brief. 1.02. What is the ratio of the Mortality Rate(per 1000 female or male adults) of Serbia in 1978 to that in 1980?
Provide a short and direct response. 1.01. What is the ratio of the Mortality Rate(per 1000 female or male adults) in Guyana in 1978 to that in 1981?
Your response must be concise. 1.04. What is the ratio of the Mortality Rate(per 1000 female or male adults) in Paraguay in 1978 to that in 1981?
Your answer should be very brief. 1. What is the ratio of the Mortality Rate(per 1000 female or male adults) of Serbia in 1978 to that in 1981?
Provide a short and direct response. 1.02. What is the ratio of the Mortality Rate(per 1000 female or male adults) of Guyana in 1978 to that in 1982?
Provide a short and direct response. 1.05. What is the ratio of the Mortality Rate(per 1000 female or male adults) in Paraguay in 1978 to that in 1982?
Keep it short and to the point. 1. What is the ratio of the Mortality Rate(per 1000 female or male adults) in Serbia in 1978 to that in 1982?
Your response must be concise. 1.02. What is the ratio of the Mortality Rate(per 1000 female or male adults) of Guyana in 1979 to that in 1980?
Your answer should be very brief. 1.01. What is the ratio of the Mortality Rate(per 1000 female or male adults) in Paraguay in 1979 to that in 1980?
Provide a succinct answer. 1. What is the ratio of the Mortality Rate(per 1000 female or male adults) of Serbia in 1979 to that in 1980?
Provide a short and direct response. 1.01. What is the ratio of the Mortality Rate(per 1000 female or male adults) in Guyana in 1979 to that in 1981?
Make the answer very short. 1.02. What is the ratio of the Mortality Rate(per 1000 female or male adults) in Serbia in 1979 to that in 1981?
Offer a very short reply. 1.01. What is the ratio of the Mortality Rate(per 1000 female or male adults) in Guyana in 1979 to that in 1982?
Offer a terse response. 1.04. What is the ratio of the Mortality Rate(per 1000 female or male adults) in Paraguay in 1979 to that in 1982?
Your answer should be compact. 1. What is the ratio of the Mortality Rate(per 1000 female or male adults) of Serbia in 1979 to that in 1982?
Keep it short and to the point. 1.02. What is the ratio of the Mortality Rate(per 1000 female or male adults) in Guyana in 1980 to that in 1981?
Ensure brevity in your answer.  1.01. What is the ratio of the Mortality Rate(per 1000 female or male adults) of Paraguay in 1980 to that in 1981?
Keep it short and to the point. 1. What is the ratio of the Mortality Rate(per 1000 female or male adults) in Serbia in 1980 to that in 1982?
Give a very brief answer. 1.01. What is the ratio of the Mortality Rate(per 1000 female or male adults) of Guyana in 1981 to that in 1982?
Provide a short and direct response. 1.01. What is the ratio of the Mortality Rate(per 1000 female or male adults) in Paraguay in 1981 to that in 1982?
Make the answer very short. 1. What is the ratio of the Mortality Rate(per 1000 female or male adults) of Serbia in 1981 to that in 1982?
Provide a succinct answer. 1.01. What is the difference between the highest and the second highest Mortality Rate(per 1000 female or male adults) in Guyana?
Make the answer very short. 2.56. What is the difference between the highest and the second highest Mortality Rate(per 1000 female or male adults) of Paraguay?
Give a very brief answer. 0.2. What is the difference between the highest and the second highest Mortality Rate(per 1000 female or male adults) of Serbia?
Provide a short and direct response. 1.5. What is the difference between the highest and the lowest Mortality Rate(per 1000 female or male adults) of Guyana?
Keep it short and to the point. 16.48. What is the difference between the highest and the lowest Mortality Rate(per 1000 female or male adults) of Paraguay?
Offer a terse response. 1.32. What is the difference between the highest and the lowest Mortality Rate(per 1000 female or male adults) in Serbia?
Your response must be concise. 6.49. 